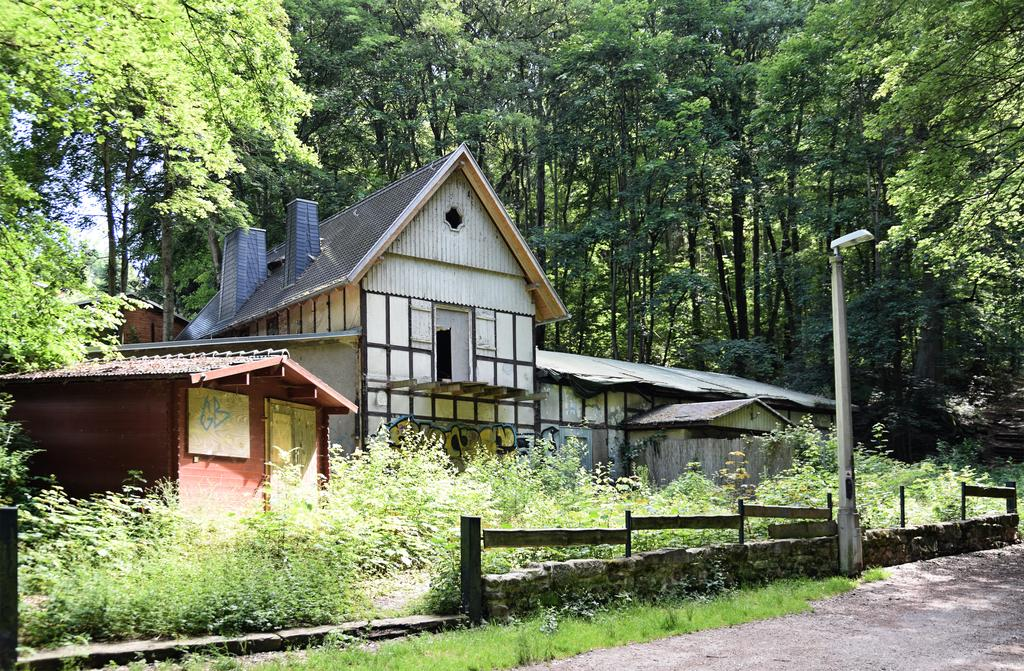What type of structures can be seen in the image? There are houses in the image. What other natural elements are present in the image? There are trees in the image. What type of fencing is visible in the image? There is wooden fencing in the image. What type of man-made object can be seen in the image? There is a light pole in the image. What is the color of the sky in the image? The sky appears to be white in color. How many degrees does the doll have in the image? There is no doll present in the image, so it is not possible to determine the number of degrees it might have. What type of spark can be seen coming from the trees in the image? There is no spark visible in the image; the trees are not on fire or displaying any unusual activity. 